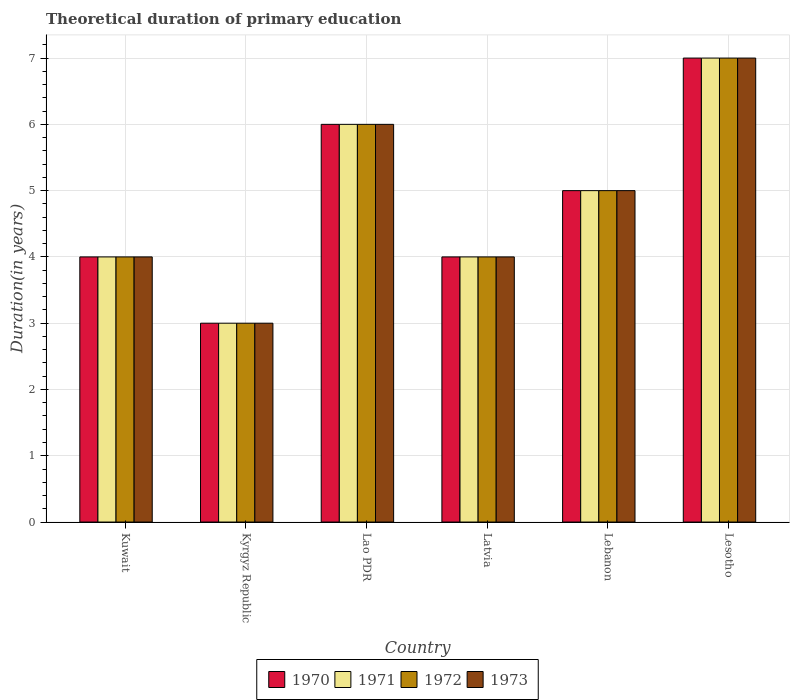How many different coloured bars are there?
Offer a very short reply. 4. Are the number of bars on each tick of the X-axis equal?
Provide a short and direct response. Yes. How many bars are there on the 2nd tick from the left?
Keep it short and to the point. 4. What is the label of the 5th group of bars from the left?
Offer a terse response. Lebanon. In how many cases, is the number of bars for a given country not equal to the number of legend labels?
Give a very brief answer. 0. What is the total theoretical duration of primary education in 1972 in Lebanon?
Ensure brevity in your answer.  5. Across all countries, what is the maximum total theoretical duration of primary education in 1973?
Offer a terse response. 7. In which country was the total theoretical duration of primary education in 1971 maximum?
Ensure brevity in your answer.  Lesotho. In which country was the total theoretical duration of primary education in 1972 minimum?
Ensure brevity in your answer.  Kyrgyz Republic. What is the difference between the total theoretical duration of primary education in 1971 in Kuwait and that in Lebanon?
Offer a terse response. -1. What is the average total theoretical duration of primary education in 1973 per country?
Provide a short and direct response. 4.83. What is the difference between the total theoretical duration of primary education of/in 1973 and total theoretical duration of primary education of/in 1972 in Kuwait?
Your answer should be very brief. 0. What is the ratio of the total theoretical duration of primary education in 1972 in Lao PDR to that in Lesotho?
Provide a succinct answer. 0.86. Is the total theoretical duration of primary education in 1972 in Kuwait less than that in Lesotho?
Provide a short and direct response. Yes. Is the difference between the total theoretical duration of primary education in 1973 in Latvia and Lesotho greater than the difference between the total theoretical duration of primary education in 1972 in Latvia and Lesotho?
Offer a very short reply. No. What is the difference between the highest and the second highest total theoretical duration of primary education in 1971?
Ensure brevity in your answer.  -1. What is the difference between the highest and the lowest total theoretical duration of primary education in 1970?
Provide a short and direct response. 4. What does the 2nd bar from the left in Lesotho represents?
Ensure brevity in your answer.  1971. What does the 1st bar from the right in Lao PDR represents?
Offer a terse response. 1973. How many bars are there?
Offer a terse response. 24. Are all the bars in the graph horizontal?
Keep it short and to the point. No. How many countries are there in the graph?
Provide a short and direct response. 6. Does the graph contain grids?
Keep it short and to the point. Yes. Where does the legend appear in the graph?
Provide a short and direct response. Bottom center. How many legend labels are there?
Provide a short and direct response. 4. What is the title of the graph?
Make the answer very short. Theoretical duration of primary education. What is the label or title of the X-axis?
Your response must be concise. Country. What is the label or title of the Y-axis?
Offer a very short reply. Duration(in years). What is the Duration(in years) in 1970 in Kuwait?
Make the answer very short. 4. What is the Duration(in years) in 1971 in Kuwait?
Provide a succinct answer. 4. What is the Duration(in years) in 1972 in Kuwait?
Make the answer very short. 4. What is the Duration(in years) in 1973 in Kuwait?
Ensure brevity in your answer.  4. What is the Duration(in years) in 1973 in Kyrgyz Republic?
Provide a succinct answer. 3. What is the Duration(in years) of 1970 in Lao PDR?
Provide a short and direct response. 6. What is the Duration(in years) of 1972 in Lao PDR?
Make the answer very short. 6. What is the Duration(in years) of 1973 in Lao PDR?
Make the answer very short. 6. What is the Duration(in years) of 1970 in Latvia?
Provide a short and direct response. 4. What is the Duration(in years) of 1971 in Latvia?
Give a very brief answer. 4. What is the Duration(in years) of 1972 in Latvia?
Give a very brief answer. 4. What is the Duration(in years) of 1973 in Latvia?
Your answer should be compact. 4. What is the Duration(in years) of 1972 in Lebanon?
Give a very brief answer. 5. What is the Duration(in years) of 1970 in Lesotho?
Ensure brevity in your answer.  7. What is the Duration(in years) of 1971 in Lesotho?
Keep it short and to the point. 7. What is the Duration(in years) of 1972 in Lesotho?
Keep it short and to the point. 7. Across all countries, what is the maximum Duration(in years) in 1973?
Offer a terse response. 7. Across all countries, what is the minimum Duration(in years) in 1972?
Offer a terse response. 3. What is the total Duration(in years) in 1970 in the graph?
Your answer should be compact. 29. What is the total Duration(in years) of 1971 in the graph?
Ensure brevity in your answer.  29. What is the difference between the Duration(in years) of 1971 in Kuwait and that in Kyrgyz Republic?
Ensure brevity in your answer.  1. What is the difference between the Duration(in years) in 1970 in Kuwait and that in Lao PDR?
Give a very brief answer. -2. What is the difference between the Duration(in years) of 1971 in Kuwait and that in Lao PDR?
Provide a short and direct response. -2. What is the difference between the Duration(in years) of 1972 in Kuwait and that in Lao PDR?
Ensure brevity in your answer.  -2. What is the difference between the Duration(in years) in 1970 in Kuwait and that in Latvia?
Provide a short and direct response. 0. What is the difference between the Duration(in years) in 1971 in Kuwait and that in Lebanon?
Provide a short and direct response. -1. What is the difference between the Duration(in years) of 1972 in Kuwait and that in Lebanon?
Make the answer very short. -1. What is the difference between the Duration(in years) of 1970 in Kuwait and that in Lesotho?
Make the answer very short. -3. What is the difference between the Duration(in years) in 1971 in Kuwait and that in Lesotho?
Provide a short and direct response. -3. What is the difference between the Duration(in years) of 1972 in Kuwait and that in Lesotho?
Offer a terse response. -3. What is the difference between the Duration(in years) in 1970 in Kyrgyz Republic and that in Lao PDR?
Provide a short and direct response. -3. What is the difference between the Duration(in years) of 1973 in Kyrgyz Republic and that in Lao PDR?
Give a very brief answer. -3. What is the difference between the Duration(in years) in 1971 in Kyrgyz Republic and that in Latvia?
Provide a succinct answer. -1. What is the difference between the Duration(in years) of 1973 in Kyrgyz Republic and that in Latvia?
Ensure brevity in your answer.  -1. What is the difference between the Duration(in years) in 1970 in Kyrgyz Republic and that in Lebanon?
Offer a very short reply. -2. What is the difference between the Duration(in years) of 1971 in Kyrgyz Republic and that in Lebanon?
Give a very brief answer. -2. What is the difference between the Duration(in years) in 1972 in Kyrgyz Republic and that in Lebanon?
Make the answer very short. -2. What is the difference between the Duration(in years) of 1973 in Kyrgyz Republic and that in Lebanon?
Keep it short and to the point. -2. What is the difference between the Duration(in years) of 1970 in Kyrgyz Republic and that in Lesotho?
Ensure brevity in your answer.  -4. What is the difference between the Duration(in years) of 1972 in Kyrgyz Republic and that in Lesotho?
Keep it short and to the point. -4. What is the difference between the Duration(in years) of 1973 in Kyrgyz Republic and that in Lesotho?
Provide a succinct answer. -4. What is the difference between the Duration(in years) in 1970 in Lao PDR and that in Latvia?
Offer a terse response. 2. What is the difference between the Duration(in years) in 1973 in Lao PDR and that in Latvia?
Your answer should be compact. 2. What is the difference between the Duration(in years) in 1970 in Lao PDR and that in Lebanon?
Provide a succinct answer. 1. What is the difference between the Duration(in years) in 1971 in Lao PDR and that in Lebanon?
Your answer should be very brief. 1. What is the difference between the Duration(in years) of 1972 in Lao PDR and that in Lebanon?
Give a very brief answer. 1. What is the difference between the Duration(in years) in 1970 in Lao PDR and that in Lesotho?
Your answer should be compact. -1. What is the difference between the Duration(in years) of 1971 in Lao PDR and that in Lesotho?
Make the answer very short. -1. What is the difference between the Duration(in years) in 1972 in Lao PDR and that in Lesotho?
Provide a short and direct response. -1. What is the difference between the Duration(in years) of 1973 in Lao PDR and that in Lesotho?
Ensure brevity in your answer.  -1. What is the difference between the Duration(in years) of 1970 in Latvia and that in Lebanon?
Your response must be concise. -1. What is the difference between the Duration(in years) of 1971 in Latvia and that in Lebanon?
Provide a short and direct response. -1. What is the difference between the Duration(in years) of 1972 in Latvia and that in Lebanon?
Offer a terse response. -1. What is the difference between the Duration(in years) of 1970 in Latvia and that in Lesotho?
Keep it short and to the point. -3. What is the difference between the Duration(in years) in 1972 in Latvia and that in Lesotho?
Keep it short and to the point. -3. What is the difference between the Duration(in years) of 1970 in Lebanon and that in Lesotho?
Ensure brevity in your answer.  -2. What is the difference between the Duration(in years) of 1971 in Lebanon and that in Lesotho?
Your response must be concise. -2. What is the difference between the Duration(in years) of 1973 in Lebanon and that in Lesotho?
Ensure brevity in your answer.  -2. What is the difference between the Duration(in years) of 1970 in Kuwait and the Duration(in years) of 1972 in Kyrgyz Republic?
Provide a short and direct response. 1. What is the difference between the Duration(in years) of 1970 in Kuwait and the Duration(in years) of 1973 in Kyrgyz Republic?
Offer a very short reply. 1. What is the difference between the Duration(in years) of 1972 in Kuwait and the Duration(in years) of 1973 in Kyrgyz Republic?
Make the answer very short. 1. What is the difference between the Duration(in years) in 1970 in Kuwait and the Duration(in years) in 1971 in Lao PDR?
Offer a very short reply. -2. What is the difference between the Duration(in years) of 1970 in Kuwait and the Duration(in years) of 1972 in Lao PDR?
Ensure brevity in your answer.  -2. What is the difference between the Duration(in years) in 1972 in Kuwait and the Duration(in years) in 1973 in Lao PDR?
Your answer should be compact. -2. What is the difference between the Duration(in years) in 1970 in Kuwait and the Duration(in years) in 1972 in Latvia?
Provide a short and direct response. 0. What is the difference between the Duration(in years) in 1970 in Kuwait and the Duration(in years) in 1973 in Latvia?
Offer a terse response. 0. What is the difference between the Duration(in years) of 1970 in Kuwait and the Duration(in years) of 1972 in Lebanon?
Your response must be concise. -1. What is the difference between the Duration(in years) of 1971 in Kuwait and the Duration(in years) of 1972 in Lebanon?
Keep it short and to the point. -1. What is the difference between the Duration(in years) of 1971 in Kuwait and the Duration(in years) of 1973 in Lebanon?
Provide a short and direct response. -1. What is the difference between the Duration(in years) of 1972 in Kuwait and the Duration(in years) of 1973 in Lebanon?
Ensure brevity in your answer.  -1. What is the difference between the Duration(in years) in 1970 in Kuwait and the Duration(in years) in 1971 in Lesotho?
Your answer should be very brief. -3. What is the difference between the Duration(in years) in 1970 in Kuwait and the Duration(in years) in 1973 in Lesotho?
Provide a short and direct response. -3. What is the difference between the Duration(in years) in 1971 in Kuwait and the Duration(in years) in 1972 in Lesotho?
Keep it short and to the point. -3. What is the difference between the Duration(in years) in 1972 in Kuwait and the Duration(in years) in 1973 in Lesotho?
Ensure brevity in your answer.  -3. What is the difference between the Duration(in years) in 1970 in Kyrgyz Republic and the Duration(in years) in 1972 in Lao PDR?
Give a very brief answer. -3. What is the difference between the Duration(in years) in 1970 in Kyrgyz Republic and the Duration(in years) in 1973 in Lao PDR?
Offer a terse response. -3. What is the difference between the Duration(in years) of 1971 in Kyrgyz Republic and the Duration(in years) of 1972 in Lao PDR?
Offer a terse response. -3. What is the difference between the Duration(in years) in 1970 in Kyrgyz Republic and the Duration(in years) in 1971 in Latvia?
Provide a succinct answer. -1. What is the difference between the Duration(in years) in 1972 in Kyrgyz Republic and the Duration(in years) in 1973 in Latvia?
Your answer should be very brief. -1. What is the difference between the Duration(in years) in 1970 in Kyrgyz Republic and the Duration(in years) in 1971 in Lebanon?
Ensure brevity in your answer.  -2. What is the difference between the Duration(in years) in 1970 in Kyrgyz Republic and the Duration(in years) in 1972 in Lebanon?
Provide a short and direct response. -2. What is the difference between the Duration(in years) of 1970 in Kyrgyz Republic and the Duration(in years) of 1973 in Lebanon?
Your answer should be very brief. -2. What is the difference between the Duration(in years) in 1971 in Kyrgyz Republic and the Duration(in years) in 1972 in Lebanon?
Provide a succinct answer. -2. What is the difference between the Duration(in years) of 1971 in Kyrgyz Republic and the Duration(in years) of 1973 in Lebanon?
Ensure brevity in your answer.  -2. What is the difference between the Duration(in years) of 1970 in Kyrgyz Republic and the Duration(in years) of 1973 in Lesotho?
Give a very brief answer. -4. What is the difference between the Duration(in years) of 1971 in Kyrgyz Republic and the Duration(in years) of 1973 in Lesotho?
Provide a succinct answer. -4. What is the difference between the Duration(in years) of 1972 in Kyrgyz Republic and the Duration(in years) of 1973 in Lesotho?
Ensure brevity in your answer.  -4. What is the difference between the Duration(in years) in 1970 in Lao PDR and the Duration(in years) in 1972 in Latvia?
Keep it short and to the point. 2. What is the difference between the Duration(in years) of 1970 in Lao PDR and the Duration(in years) of 1973 in Latvia?
Give a very brief answer. 2. What is the difference between the Duration(in years) of 1971 in Lao PDR and the Duration(in years) of 1972 in Latvia?
Your answer should be very brief. 2. What is the difference between the Duration(in years) in 1970 in Lao PDR and the Duration(in years) in 1972 in Lebanon?
Give a very brief answer. 1. What is the difference between the Duration(in years) in 1971 in Lao PDR and the Duration(in years) in 1972 in Lebanon?
Provide a succinct answer. 1. What is the difference between the Duration(in years) of 1972 in Lao PDR and the Duration(in years) of 1973 in Lebanon?
Provide a succinct answer. 1. What is the difference between the Duration(in years) of 1970 in Lao PDR and the Duration(in years) of 1971 in Lesotho?
Provide a succinct answer. -1. What is the difference between the Duration(in years) of 1971 in Lao PDR and the Duration(in years) of 1973 in Lesotho?
Ensure brevity in your answer.  -1. What is the difference between the Duration(in years) in 1970 in Latvia and the Duration(in years) in 1972 in Lebanon?
Your answer should be compact. -1. What is the difference between the Duration(in years) in 1971 in Latvia and the Duration(in years) in 1972 in Lebanon?
Your answer should be very brief. -1. What is the difference between the Duration(in years) in 1972 in Latvia and the Duration(in years) in 1973 in Lebanon?
Make the answer very short. -1. What is the difference between the Duration(in years) in 1970 in Latvia and the Duration(in years) in 1971 in Lesotho?
Your answer should be compact. -3. What is the difference between the Duration(in years) of 1971 in Latvia and the Duration(in years) of 1973 in Lesotho?
Your answer should be compact. -3. What is the difference between the Duration(in years) of 1972 in Latvia and the Duration(in years) of 1973 in Lesotho?
Provide a succinct answer. -3. What is the difference between the Duration(in years) in 1970 in Lebanon and the Duration(in years) in 1972 in Lesotho?
Your answer should be very brief. -2. What is the difference between the Duration(in years) in 1970 in Lebanon and the Duration(in years) in 1973 in Lesotho?
Your answer should be compact. -2. What is the difference between the Duration(in years) of 1971 in Lebanon and the Duration(in years) of 1973 in Lesotho?
Your answer should be compact. -2. What is the difference between the Duration(in years) in 1972 in Lebanon and the Duration(in years) in 1973 in Lesotho?
Your answer should be very brief. -2. What is the average Duration(in years) in 1970 per country?
Give a very brief answer. 4.83. What is the average Duration(in years) in 1971 per country?
Make the answer very short. 4.83. What is the average Duration(in years) of 1972 per country?
Your answer should be very brief. 4.83. What is the average Duration(in years) of 1973 per country?
Your answer should be very brief. 4.83. What is the difference between the Duration(in years) in 1971 and Duration(in years) in 1972 in Kuwait?
Offer a very short reply. 0. What is the difference between the Duration(in years) in 1971 and Duration(in years) in 1973 in Kuwait?
Make the answer very short. 0. What is the difference between the Duration(in years) in 1970 and Duration(in years) in 1972 in Kyrgyz Republic?
Provide a short and direct response. 0. What is the difference between the Duration(in years) of 1970 and Duration(in years) of 1973 in Kyrgyz Republic?
Ensure brevity in your answer.  0. What is the difference between the Duration(in years) in 1972 and Duration(in years) in 1973 in Kyrgyz Republic?
Your response must be concise. 0. What is the difference between the Duration(in years) in 1970 and Duration(in years) in 1972 in Lao PDR?
Your response must be concise. 0. What is the difference between the Duration(in years) of 1970 and Duration(in years) of 1973 in Lao PDR?
Provide a short and direct response. 0. What is the difference between the Duration(in years) in 1971 and Duration(in years) in 1973 in Lao PDR?
Your response must be concise. 0. What is the difference between the Duration(in years) of 1971 and Duration(in years) of 1973 in Latvia?
Your response must be concise. 0. What is the difference between the Duration(in years) of 1972 and Duration(in years) of 1973 in Latvia?
Provide a succinct answer. 0. What is the difference between the Duration(in years) of 1970 and Duration(in years) of 1971 in Lebanon?
Make the answer very short. 0. What is the difference between the Duration(in years) in 1971 and Duration(in years) in 1972 in Lebanon?
Provide a short and direct response. 0. What is the difference between the Duration(in years) in 1971 and Duration(in years) in 1973 in Lebanon?
Keep it short and to the point. 0. What is the difference between the Duration(in years) in 1972 and Duration(in years) in 1973 in Lebanon?
Your response must be concise. 0. What is the difference between the Duration(in years) of 1970 and Duration(in years) of 1971 in Lesotho?
Your response must be concise. 0. What is the difference between the Duration(in years) of 1970 and Duration(in years) of 1972 in Lesotho?
Provide a succinct answer. 0. What is the difference between the Duration(in years) in 1971 and Duration(in years) in 1972 in Lesotho?
Provide a succinct answer. 0. What is the ratio of the Duration(in years) in 1971 in Kuwait to that in Kyrgyz Republic?
Ensure brevity in your answer.  1.33. What is the ratio of the Duration(in years) in 1970 in Kuwait to that in Lao PDR?
Keep it short and to the point. 0.67. What is the ratio of the Duration(in years) in 1972 in Kuwait to that in Lao PDR?
Ensure brevity in your answer.  0.67. What is the ratio of the Duration(in years) in 1971 in Kuwait to that in Latvia?
Your response must be concise. 1. What is the ratio of the Duration(in years) in 1972 in Kuwait to that in Latvia?
Provide a succinct answer. 1. What is the ratio of the Duration(in years) in 1973 in Kuwait to that in Latvia?
Ensure brevity in your answer.  1. What is the ratio of the Duration(in years) in 1970 in Kuwait to that in Lebanon?
Your answer should be very brief. 0.8. What is the ratio of the Duration(in years) of 1973 in Kuwait to that in Lebanon?
Your answer should be very brief. 0.8. What is the ratio of the Duration(in years) of 1971 in Kuwait to that in Lesotho?
Make the answer very short. 0.57. What is the ratio of the Duration(in years) in 1972 in Kuwait to that in Lesotho?
Keep it short and to the point. 0.57. What is the ratio of the Duration(in years) of 1973 in Kuwait to that in Lesotho?
Your answer should be very brief. 0.57. What is the ratio of the Duration(in years) in 1971 in Kyrgyz Republic to that in Lao PDR?
Offer a very short reply. 0.5. What is the ratio of the Duration(in years) of 1970 in Kyrgyz Republic to that in Latvia?
Your response must be concise. 0.75. What is the ratio of the Duration(in years) in 1970 in Kyrgyz Republic to that in Lebanon?
Make the answer very short. 0.6. What is the ratio of the Duration(in years) in 1972 in Kyrgyz Republic to that in Lebanon?
Offer a very short reply. 0.6. What is the ratio of the Duration(in years) in 1973 in Kyrgyz Republic to that in Lebanon?
Offer a terse response. 0.6. What is the ratio of the Duration(in years) of 1970 in Kyrgyz Republic to that in Lesotho?
Your answer should be compact. 0.43. What is the ratio of the Duration(in years) in 1971 in Kyrgyz Republic to that in Lesotho?
Keep it short and to the point. 0.43. What is the ratio of the Duration(in years) in 1972 in Kyrgyz Republic to that in Lesotho?
Provide a succinct answer. 0.43. What is the ratio of the Duration(in years) of 1973 in Kyrgyz Republic to that in Lesotho?
Keep it short and to the point. 0.43. What is the ratio of the Duration(in years) of 1970 in Lao PDR to that in Latvia?
Your response must be concise. 1.5. What is the ratio of the Duration(in years) of 1972 in Lao PDR to that in Latvia?
Offer a terse response. 1.5. What is the ratio of the Duration(in years) of 1970 in Lao PDR to that in Lebanon?
Your answer should be compact. 1.2. What is the ratio of the Duration(in years) in 1972 in Lao PDR to that in Lesotho?
Your answer should be compact. 0.86. What is the ratio of the Duration(in years) in 1973 in Latvia to that in Lebanon?
Your answer should be very brief. 0.8. What is the ratio of the Duration(in years) in 1970 in Latvia to that in Lesotho?
Offer a terse response. 0.57. What is the ratio of the Duration(in years) of 1973 in Latvia to that in Lesotho?
Provide a succinct answer. 0.57. What is the ratio of the Duration(in years) of 1973 in Lebanon to that in Lesotho?
Provide a succinct answer. 0.71. What is the difference between the highest and the second highest Duration(in years) of 1970?
Ensure brevity in your answer.  1. What is the difference between the highest and the second highest Duration(in years) of 1971?
Offer a terse response. 1. What is the difference between the highest and the second highest Duration(in years) of 1972?
Provide a succinct answer. 1. What is the difference between the highest and the lowest Duration(in years) in 1970?
Offer a terse response. 4. What is the difference between the highest and the lowest Duration(in years) of 1971?
Offer a very short reply. 4. What is the difference between the highest and the lowest Duration(in years) of 1972?
Offer a very short reply. 4. 